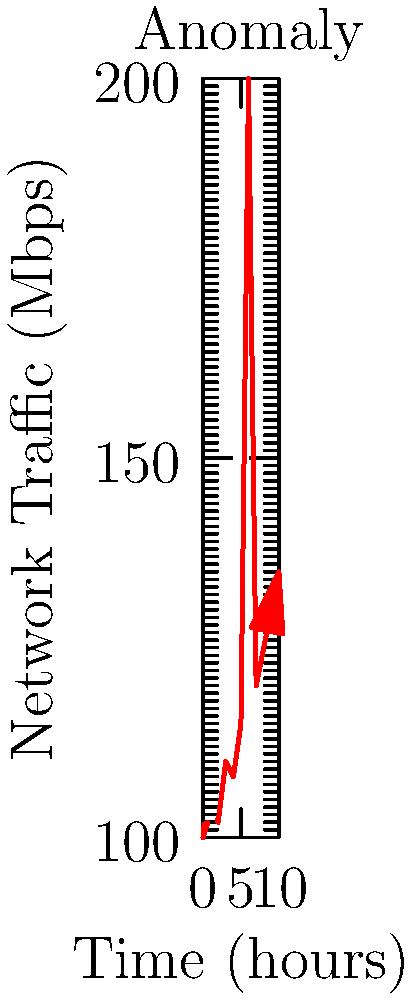As an internet security analyst, you're monitoring network traffic over a 10-hour period. The graph shows traffic volume in Mbps over time. At which hour does an anomaly occur, and what is the approximate percentage increase in traffic compared to the previous hour? To answer this question, we need to follow these steps:

1. Identify the anomaly:
   Looking at the graph, we can see a sharp spike in network traffic at hour 6.

2. Determine the traffic levels before and during the anomaly:
   - At hour 5, the traffic is approximately 115 Mbps
   - At hour 6, the traffic spikes to approximately 200 Mbps

3. Calculate the percentage increase:
   Percentage increase = $\frac{\text{Increase}}{\text{Original Value}} \times 100\%$
   
   $\text{Increase} = 200 - 115 = 85$ Mbps
   
   Percentage increase = $\frac{85}{115} \times 100\% \approx 73.9\%$

Therefore, the anomaly occurs at hour 6, with an approximate 74% increase in traffic compared to the previous hour.
Answer: Hour 6, 74% increase 